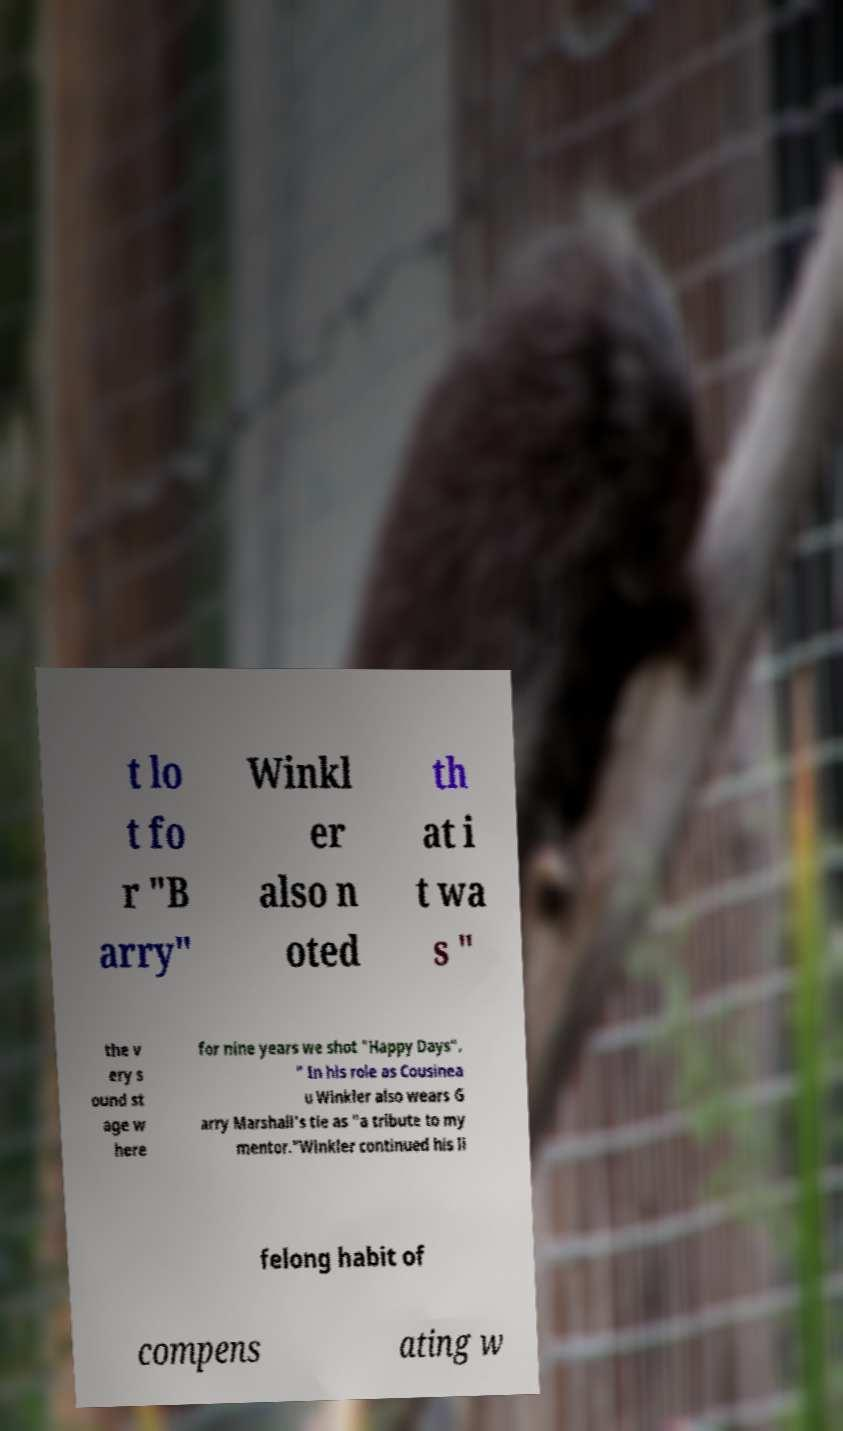I need the written content from this picture converted into text. Can you do that? t lo t fo r "B arry" Winkl er also n oted th at i t wa s " the v ery s ound st age w here for nine years we shot "Happy Days". " In his role as Cousinea u Winkler also wears G arry Marshall's tie as "a tribute to my mentor."Winkler continued his li felong habit of compens ating w 